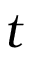Convert formula to latex. <formula><loc_0><loc_0><loc_500><loc_500>t</formula> 